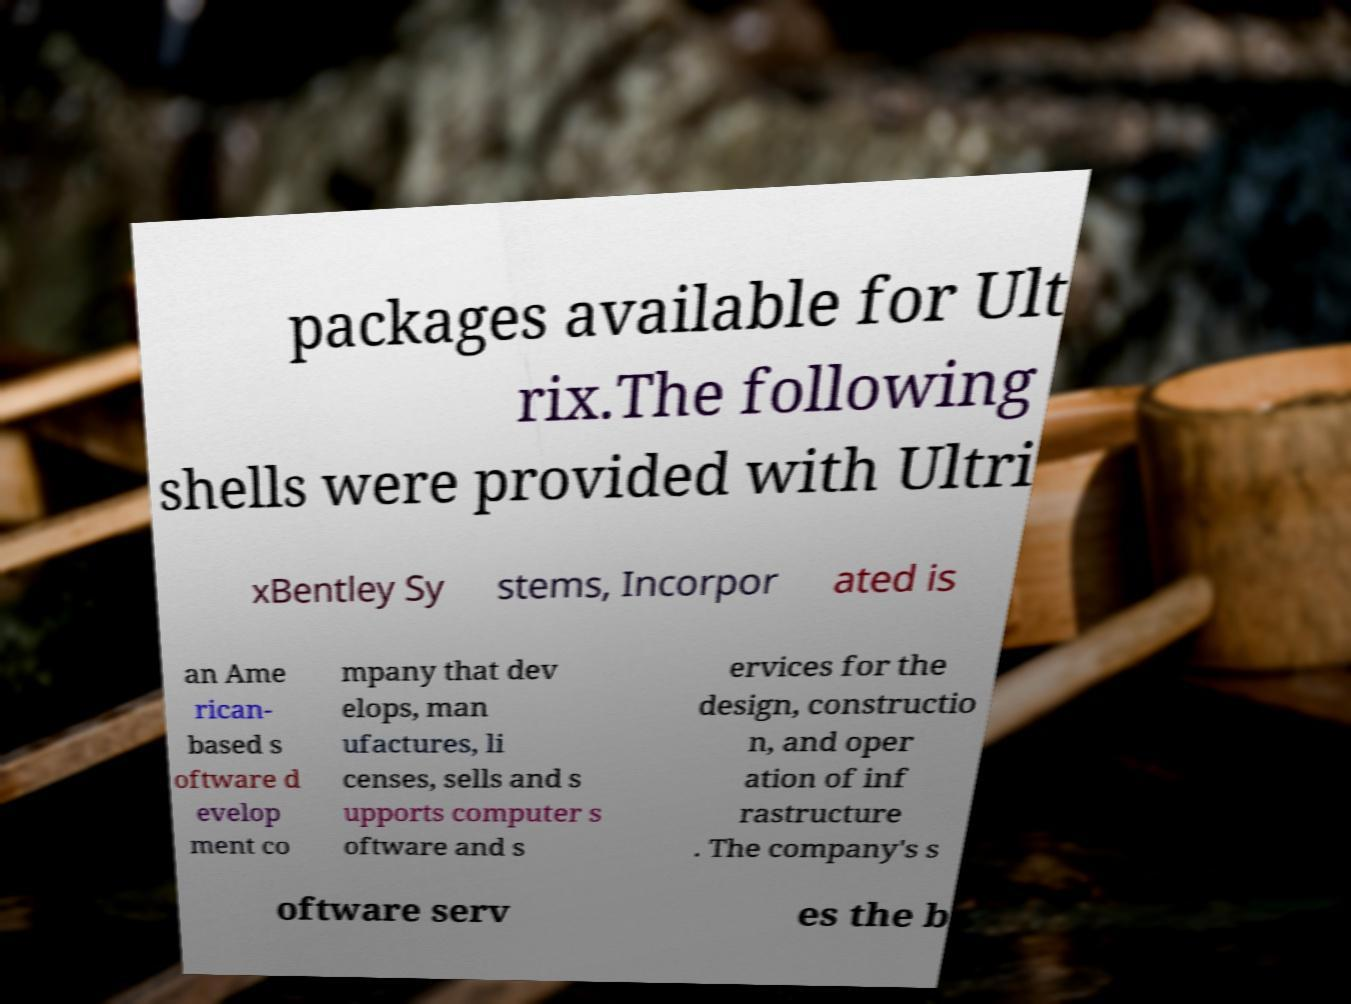Please read and relay the text visible in this image. What does it say? packages available for Ult rix.The following shells were provided with Ultri xBentley Sy stems, Incorpor ated is an Ame rican- based s oftware d evelop ment co mpany that dev elops, man ufactures, li censes, sells and s upports computer s oftware and s ervices for the design, constructio n, and oper ation of inf rastructure . The company's s oftware serv es the b 